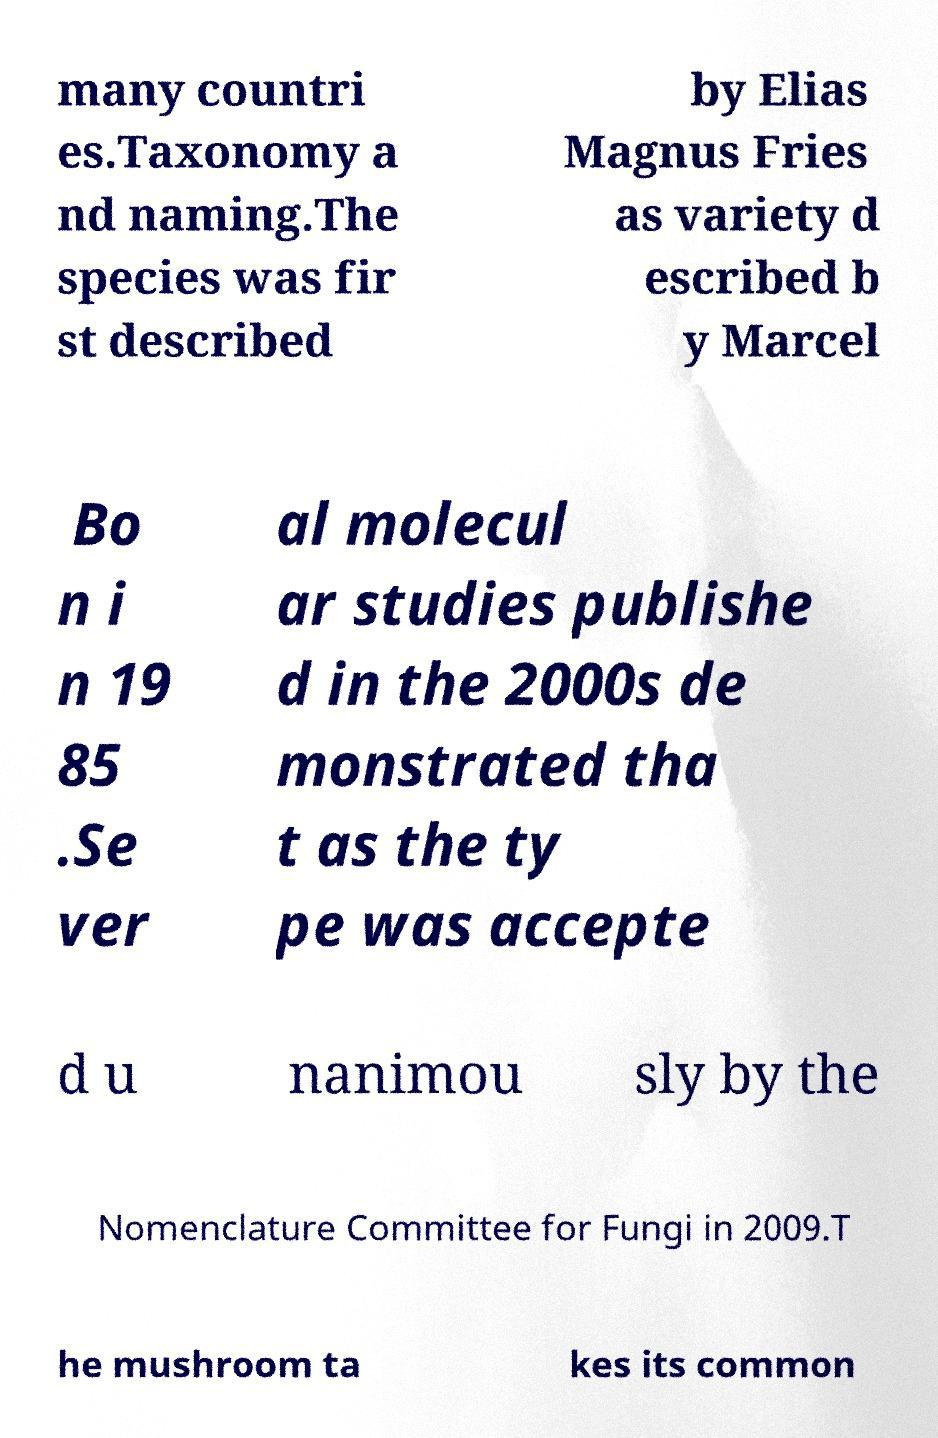I need the written content from this picture converted into text. Can you do that? many countri es.Taxonomy a nd naming.The species was fir st described by Elias Magnus Fries as variety d escribed b y Marcel Bo n i n 19 85 .Se ver al molecul ar studies publishe d in the 2000s de monstrated tha t as the ty pe was accepte d u nanimou sly by the Nomenclature Committee for Fungi in 2009.T he mushroom ta kes its common 